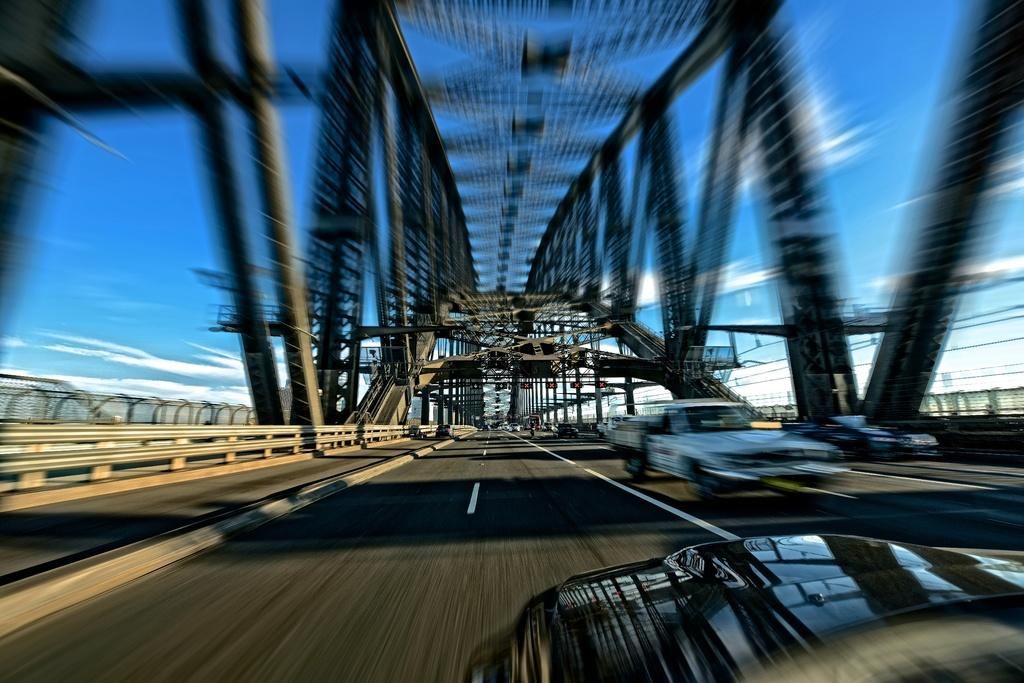What structures can be seen in the image? There are poles in the image. What else can be seen in the image besides the poles? There are vehicles and a fence in the image. What is visible in the background of the image? The sky is visible in the image, and clouds are present. What type of branch is the vehicle using to mark its territory in the image? There is no branch or indication of territory marking in the image; it features poles, vehicles, and a fence. 